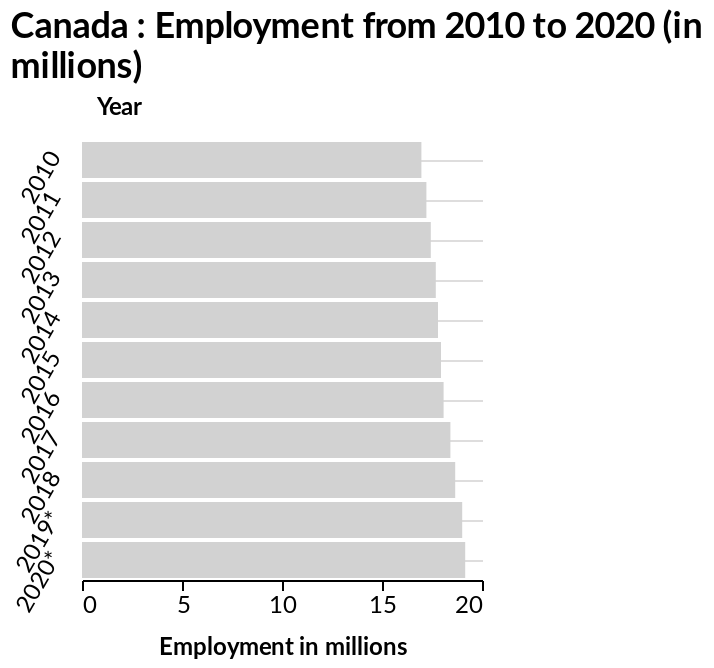<image>
In what units is the increase in employment shown on the chart? The increase in employment is shown in millions on the chart. please summary the statistics and relations of the chart Employment has slowly risen in Canadians in 10 years between 2010-2020. How many data points are represented on the bar graph? There are 11 data points represented on the bar graph, one for each year from 2010 to 2020. Describe the following image in detail Canada : Employment from 2010 to 2020 (in millions) is a bar graph. There is a categorical scale with 2010 on one end and 2020* at the other along the y-axis, marked Year. Employment in millions is plotted along the x-axis. 